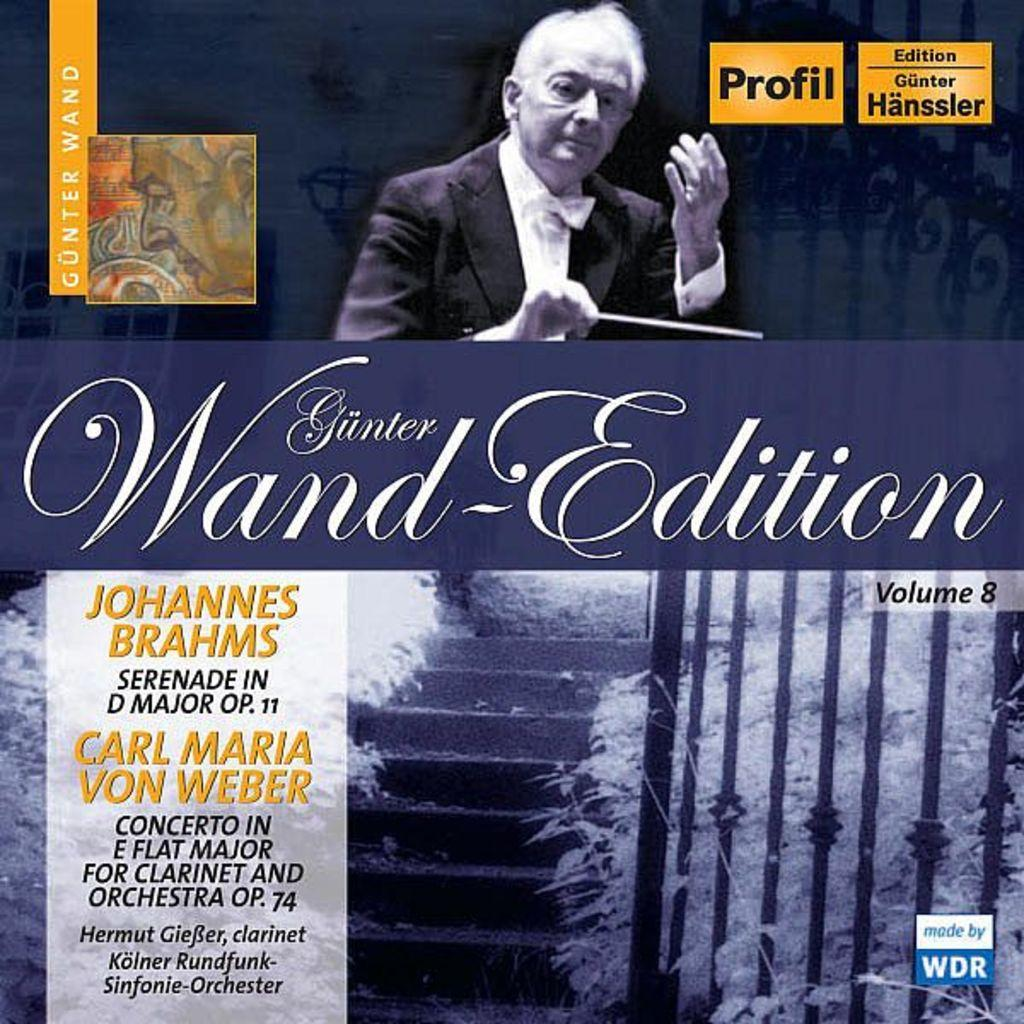What type of publication might the image be from? The image appears to be the cover page of a magazine. What can be found on the cover page besides the photo? There are statements and other texts on the page. Who or what is depicted in the photo on the cover page? There is a photo of a person on the page. What type of mark can be seen on the person's forehead in the image? There is no mark visible on the person's forehead in the image. What type of twig is used as a prop in the photo? There is no twig present in the image; it only features a person and text. 